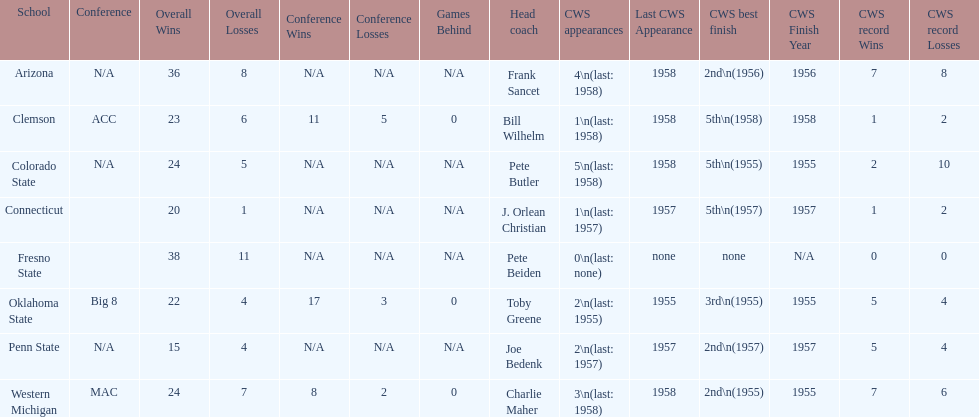How many teams had their cws best finish in 1955? 3. 